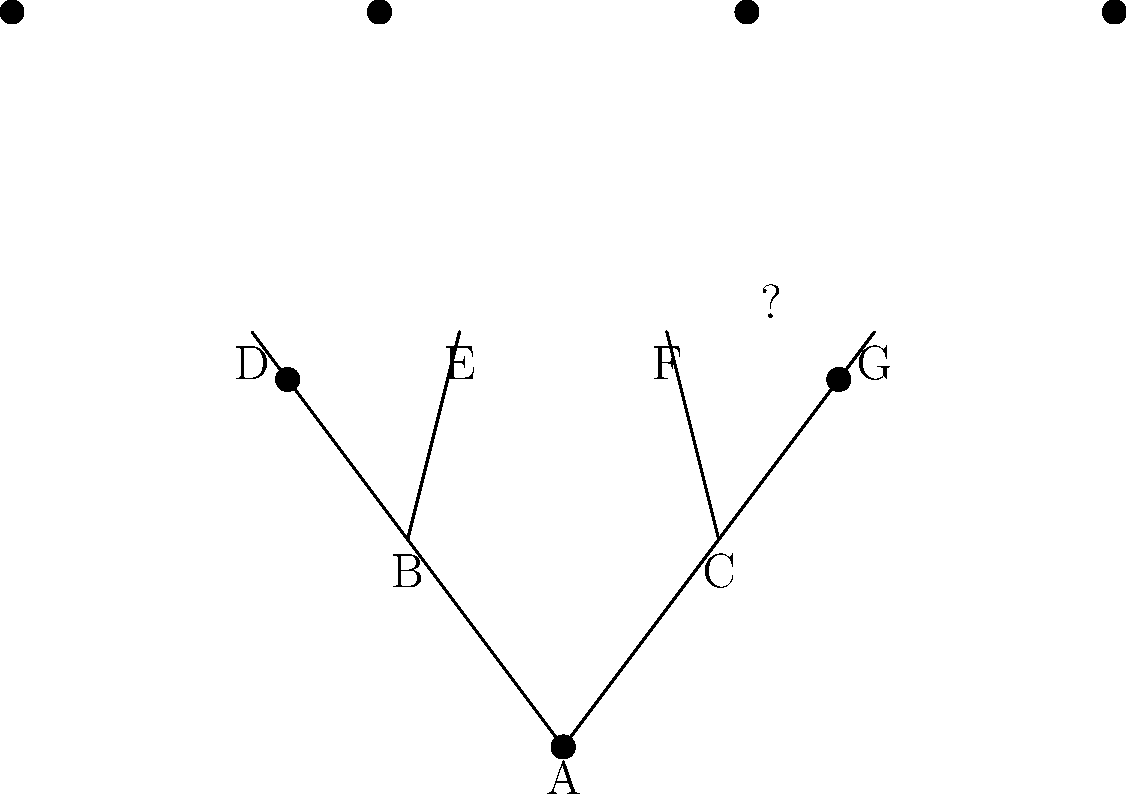In this pedigree chart of early New England settlers, person A is the subject of research. If we know that person G is not biologically related to A, what is the coefficient of relationship between A and F? To solve this problem, we need to follow these steps:

1. Understand the coefficient of relationship:
   The coefficient of relationship (r) is the proportion of genes two individuals share due to common ancestry.

2. Identify the relationship between A and F:
   F is A's grandparent (parent of C, who is A's parent).

3. Calculate the coefficient of relationship:
   For grandparent-grandchild relationships, r = 0.25 (1/4)
   This is because:
   - A child receives 50% of its genes from each parent
   - A parent passes on 50% of its genes to a child
   - So, a grandparent passes on 50% of 50% = 25% = 1/4 of its genes to a grandchild

4. Confirm that G's non-relation doesn't affect the result:
   Since G is not biologically related to A, it doesn't change the relationship between A and F.

Therefore, the coefficient of relationship between A and F is 0.25 or 1/4.
Answer: 0.25 